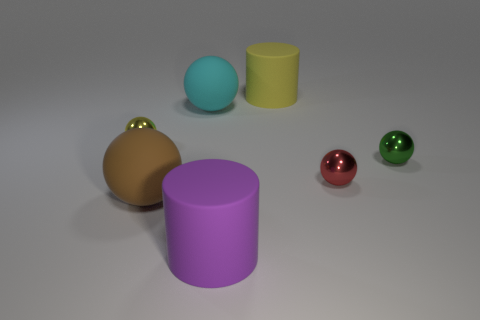Subtract all yellow spheres. How many spheres are left? 4 Subtract all brown balls. How many balls are left? 4 Subtract all gray spheres. Subtract all cyan blocks. How many spheres are left? 5 Add 3 purple spheres. How many objects exist? 10 Subtract all balls. How many objects are left? 2 Add 1 green objects. How many green objects exist? 2 Subtract 0 brown cubes. How many objects are left? 7 Subtract all big cyan rubber things. Subtract all green metallic spheres. How many objects are left? 5 Add 5 brown matte objects. How many brown matte objects are left? 6 